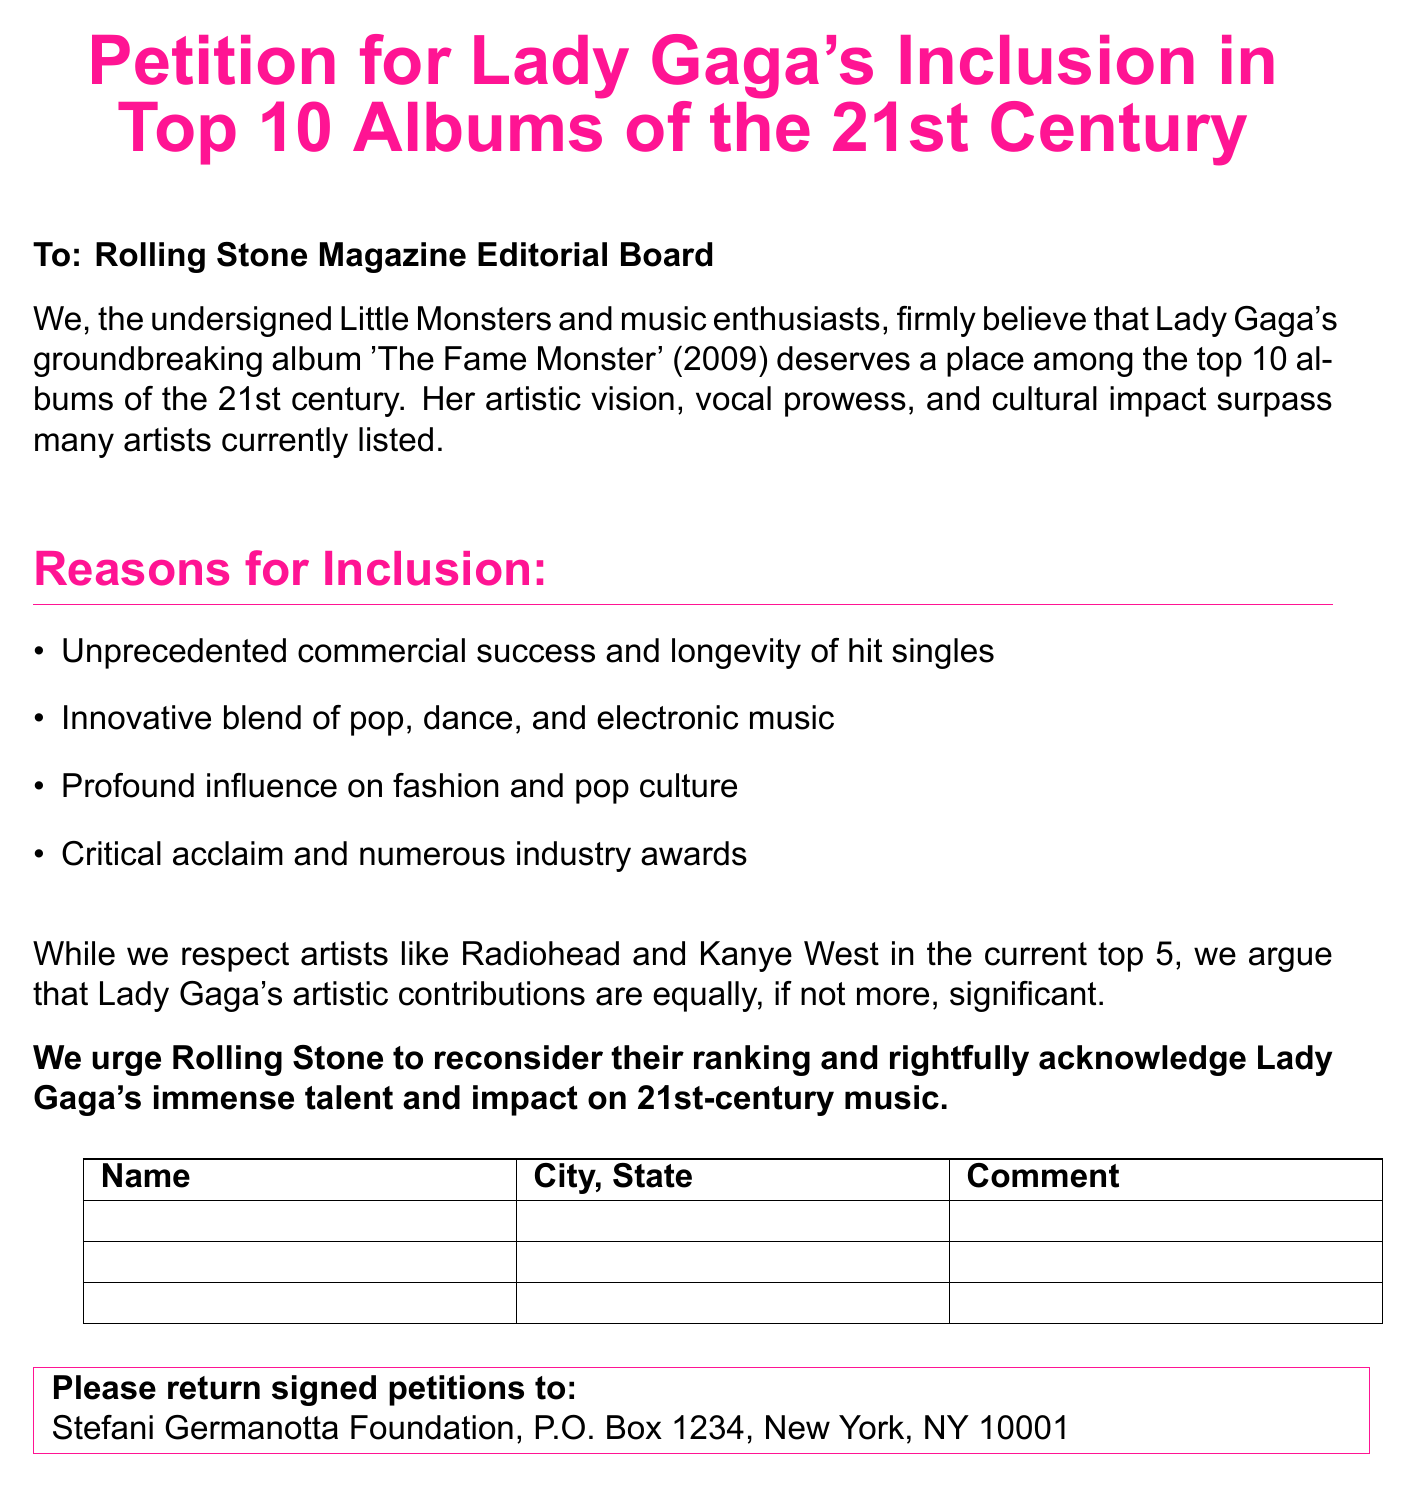What is the title of the petition? The title is explicitly stated at the beginning of the document.
Answer: Petition for Lady Gaga's Inclusion in Top 10 Albums of the 21st Century What is the year of the album mentioned? The year of the album 'The Fame Monster' is provided in the reasons for inclusion.
Answer: 2009 Who is the petition addressed to? The document specifies the recipient of the petition clearly at the start.
Answer: Rolling Stone Magazine Editorial Board What are the four reasons given for Lady Gaga's inclusion? The reasons are listed in bullet points within the document.
Answer: Commercial success, Innovative music blend, Influence on fashion, Critical acclaim What should individuals do with signed petitions? The document includes instructions on what to do with the signed petitions towards the end.
Answer: Return signed petitions to Stefani Germanotta Foundation How many signatory fields are provided in the document? The number of fields is indicated by the number of rows in the signature table.
Answer: Three fields What color is used for the title of the petition? The text color is specified in the document regarding the title format.
Answer: Gagapink Which foundation is mentioned for returning signed petitions? The foundation's name is given in the direction for returning the petitions.
Answer: Stefani Germanotta Foundation What type of document is this? The format of the content suggests the type of document it is.
Answer: Petition 